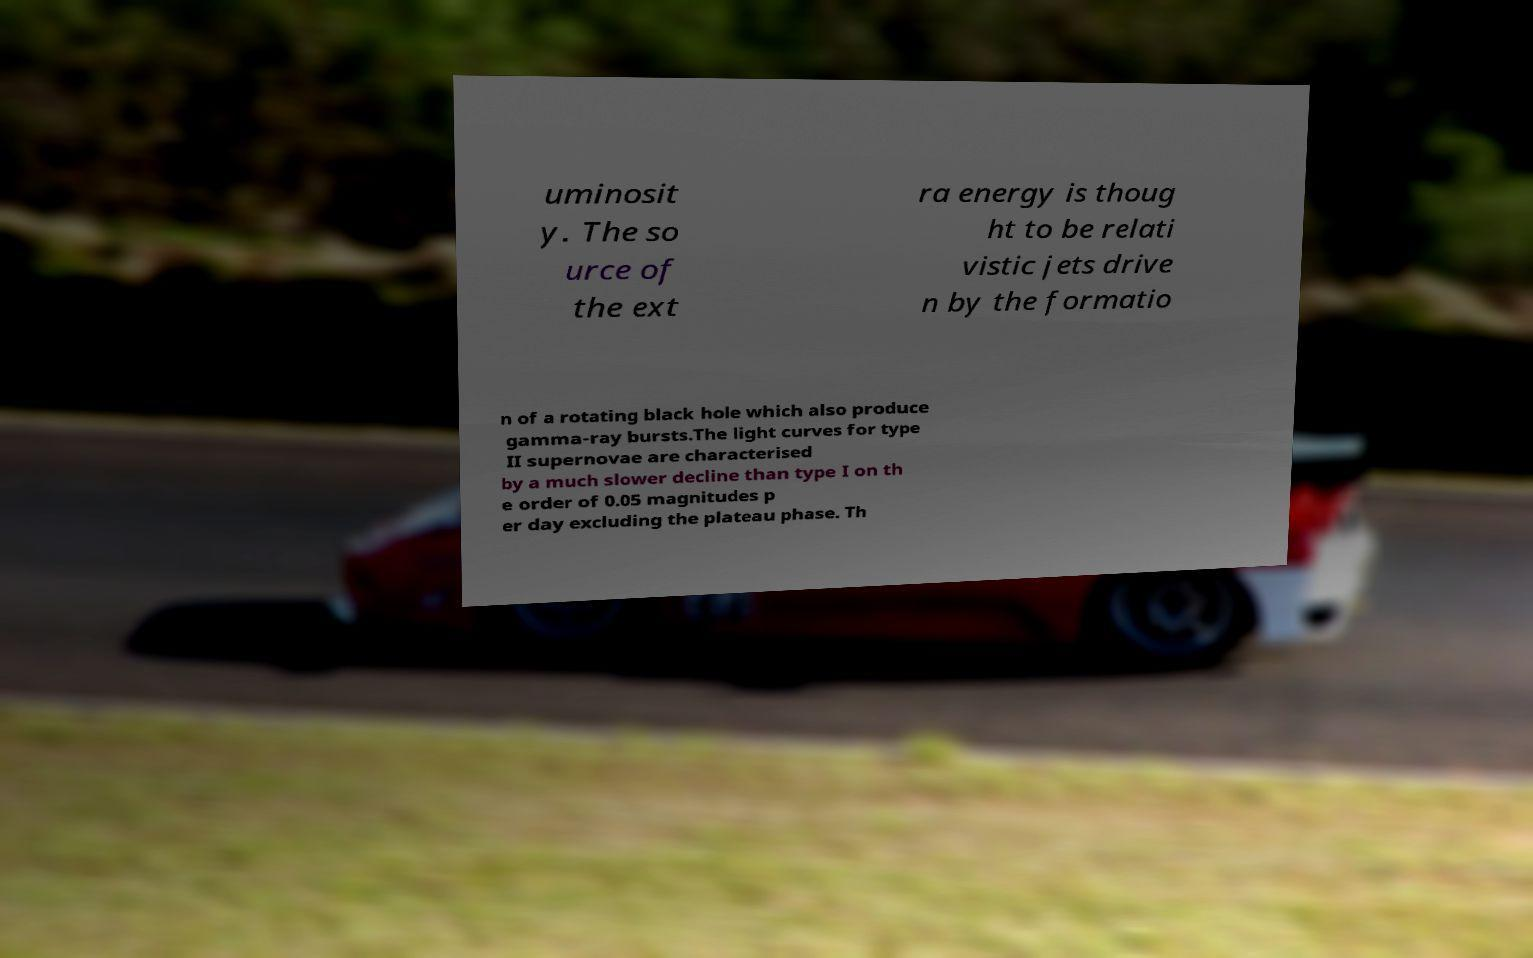Please identify and transcribe the text found in this image. uminosit y. The so urce of the ext ra energy is thoug ht to be relati vistic jets drive n by the formatio n of a rotating black hole which also produce gamma-ray bursts.The light curves for type II supernovae are characterised by a much slower decline than type I on th e order of 0.05 magnitudes p er day excluding the plateau phase. Th 